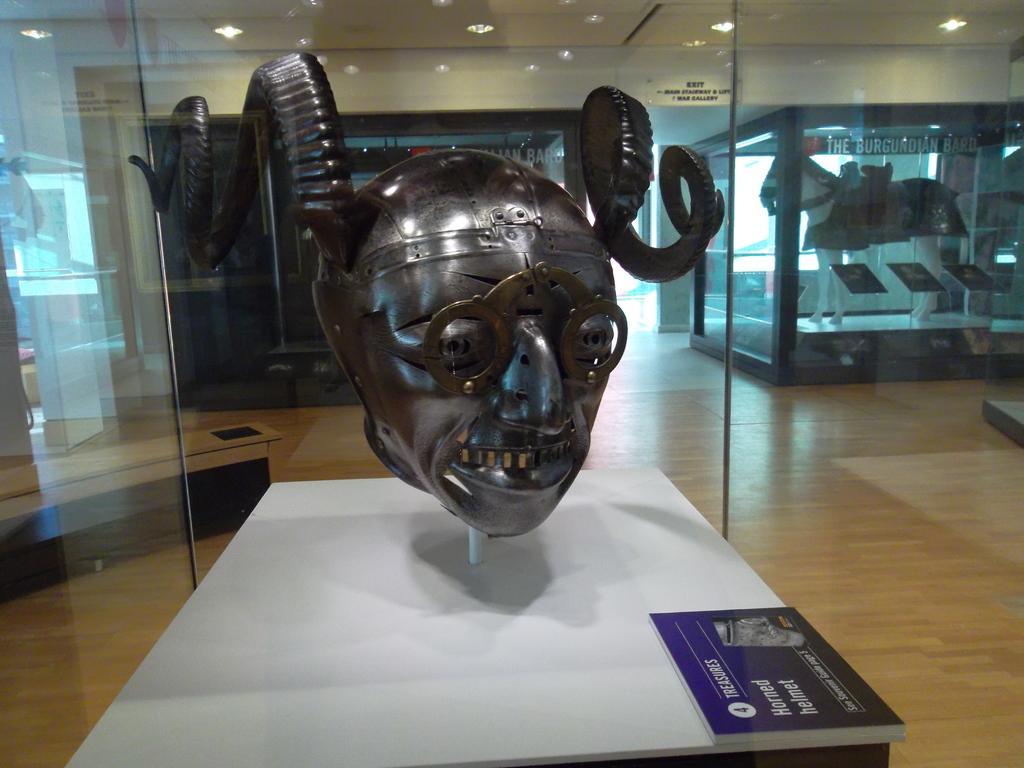Describe this image in one or two sentences. In the picture I can see a black color sculpture of a person face having horns is displayed here which is bounded in the glass box. Here we can see a few more sculptures and the ceiling lights. 